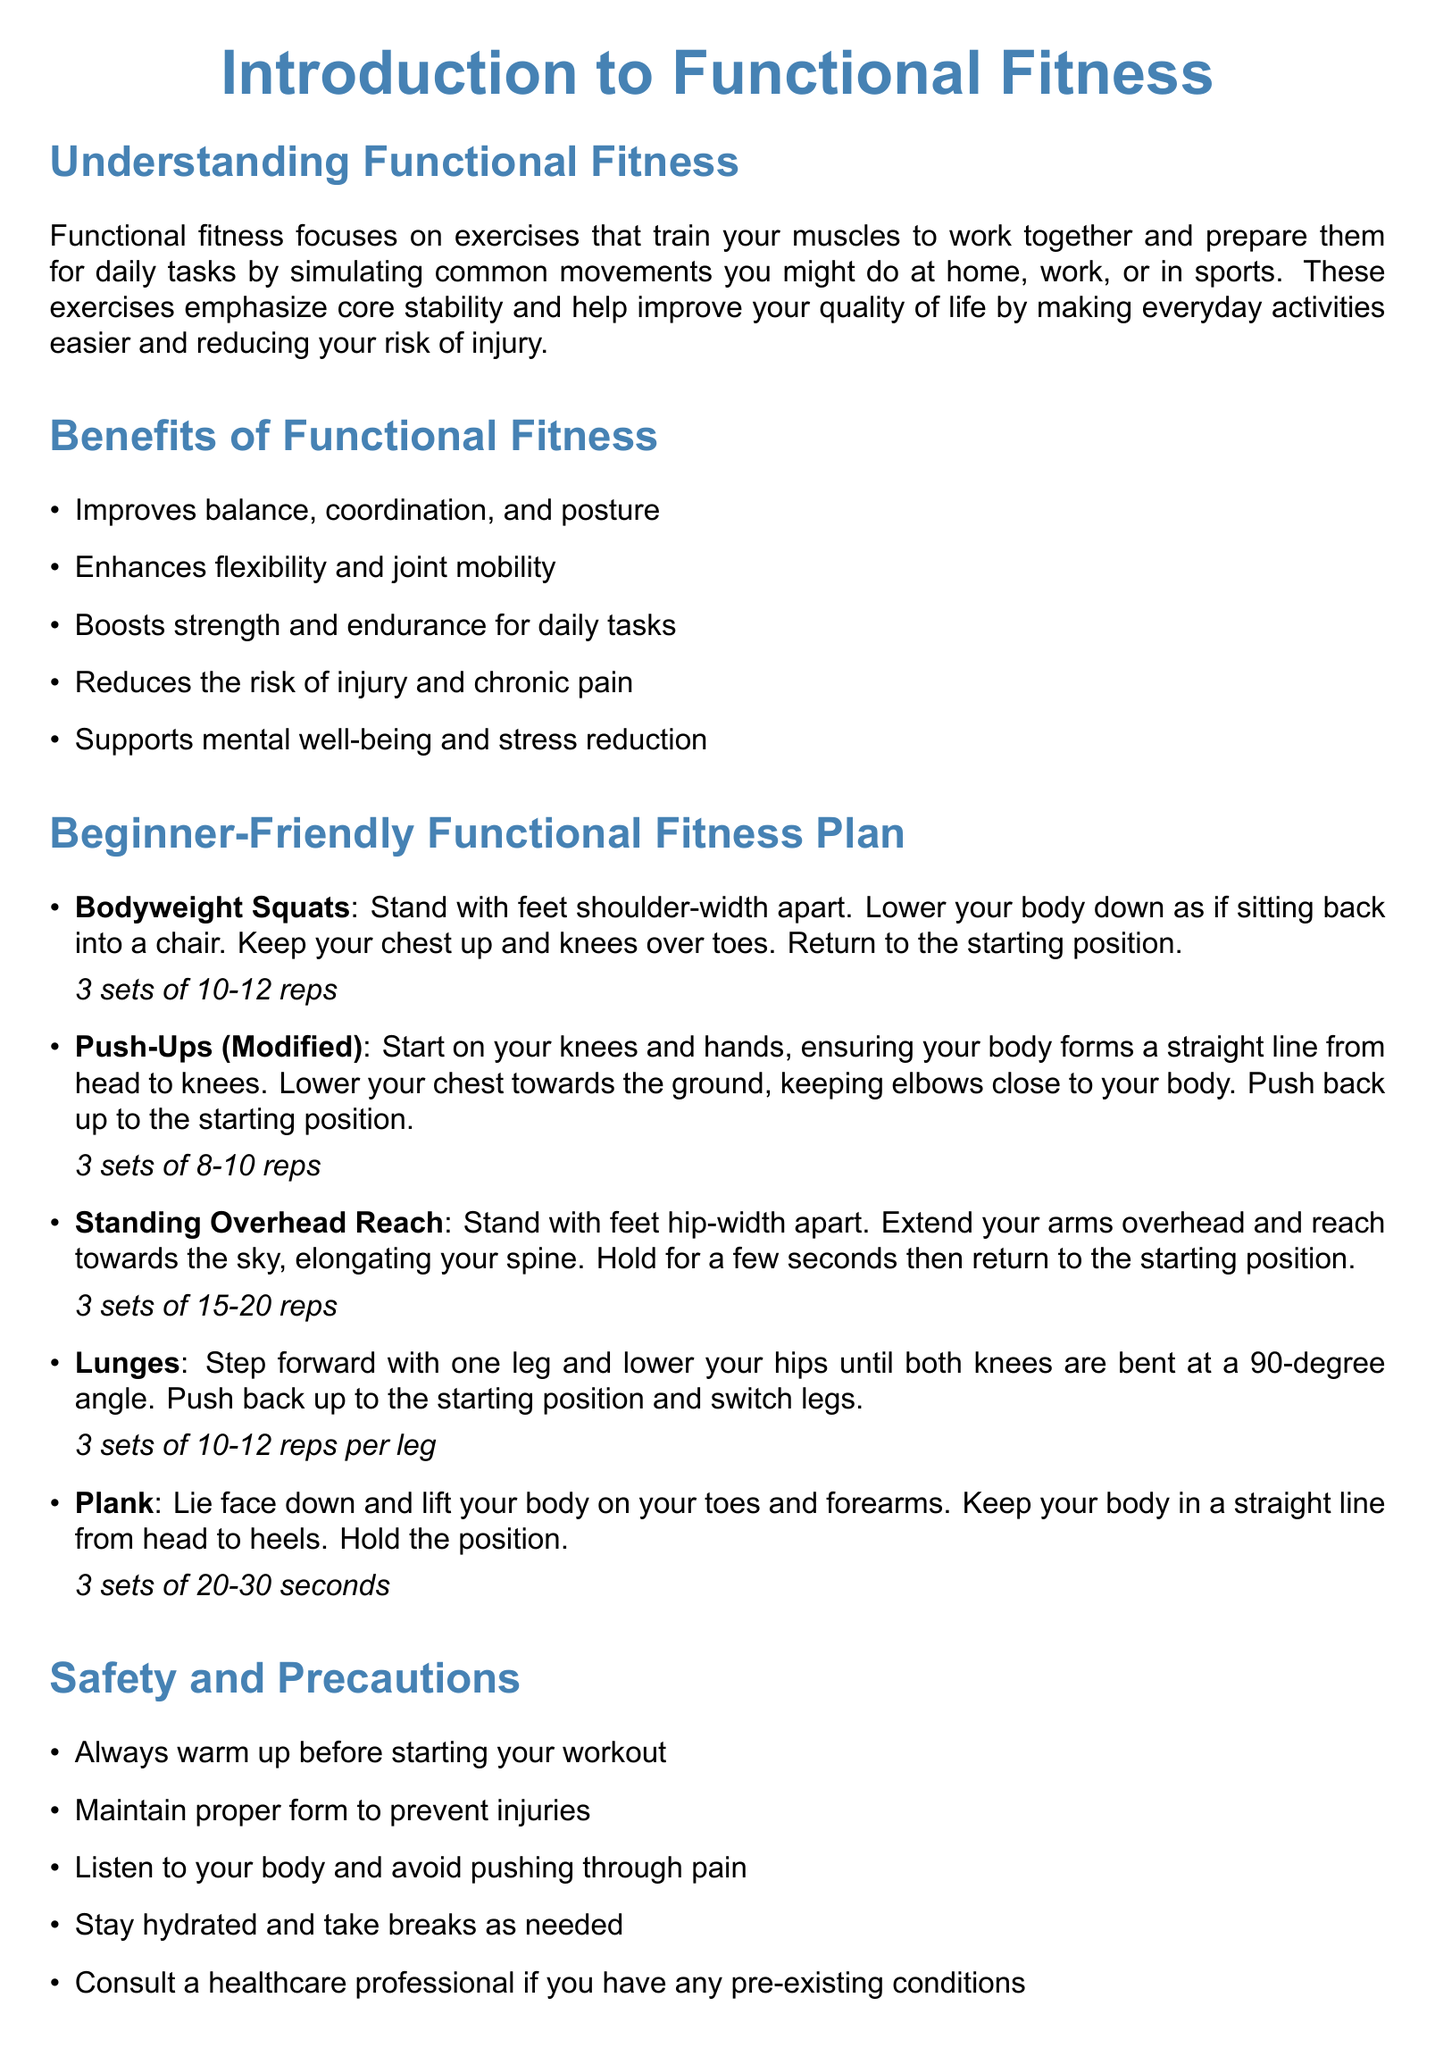What is functional fitness? Functional fitness trains muscles to work together, preparing them for daily tasks through common movements.
Answer: Exercises that train muscles together What are the benefits of functional fitness? The document lists various benefits such as improved balance, coordination, and posture among others.
Answer: Improves balance, coordination, and posture How many reps are recommended for Bodyweight Squats? The plan specifies the number of sets and reps for each exercise, including Bodyweight Squats.
Answer: 3 sets of 10-12 reps What is the duration for holding the Plank exercise? The plan provides specific durations to hold each exercise, including the Plank.
Answer: 3 sets of 20-30 seconds What psychological concepts are emphasized for motivation? The document mentions strategies related to psychological principles to integrate fitness into routine effectively.
Answer: Motivation and habit formation What should you do before starting a workout? The document advises a specific safety precaution before beginning an exercise routine.
Answer: Always warm up How many sets are suggested for Standing Overhead Reach? The number of sets for each exercise is outlined in the plan, including Standing Overhead Reach.
Answer: 3 sets of 15-20 reps Which organization provides information on Functional Fitness in the resources? The document lists various resources, including one that is an organization focused on fitness.
Answer: American Council on Exercise What is one of the safety precautions listed? The document includes specific safety measures to consider while exercising.
Answer: Maintain proper form 